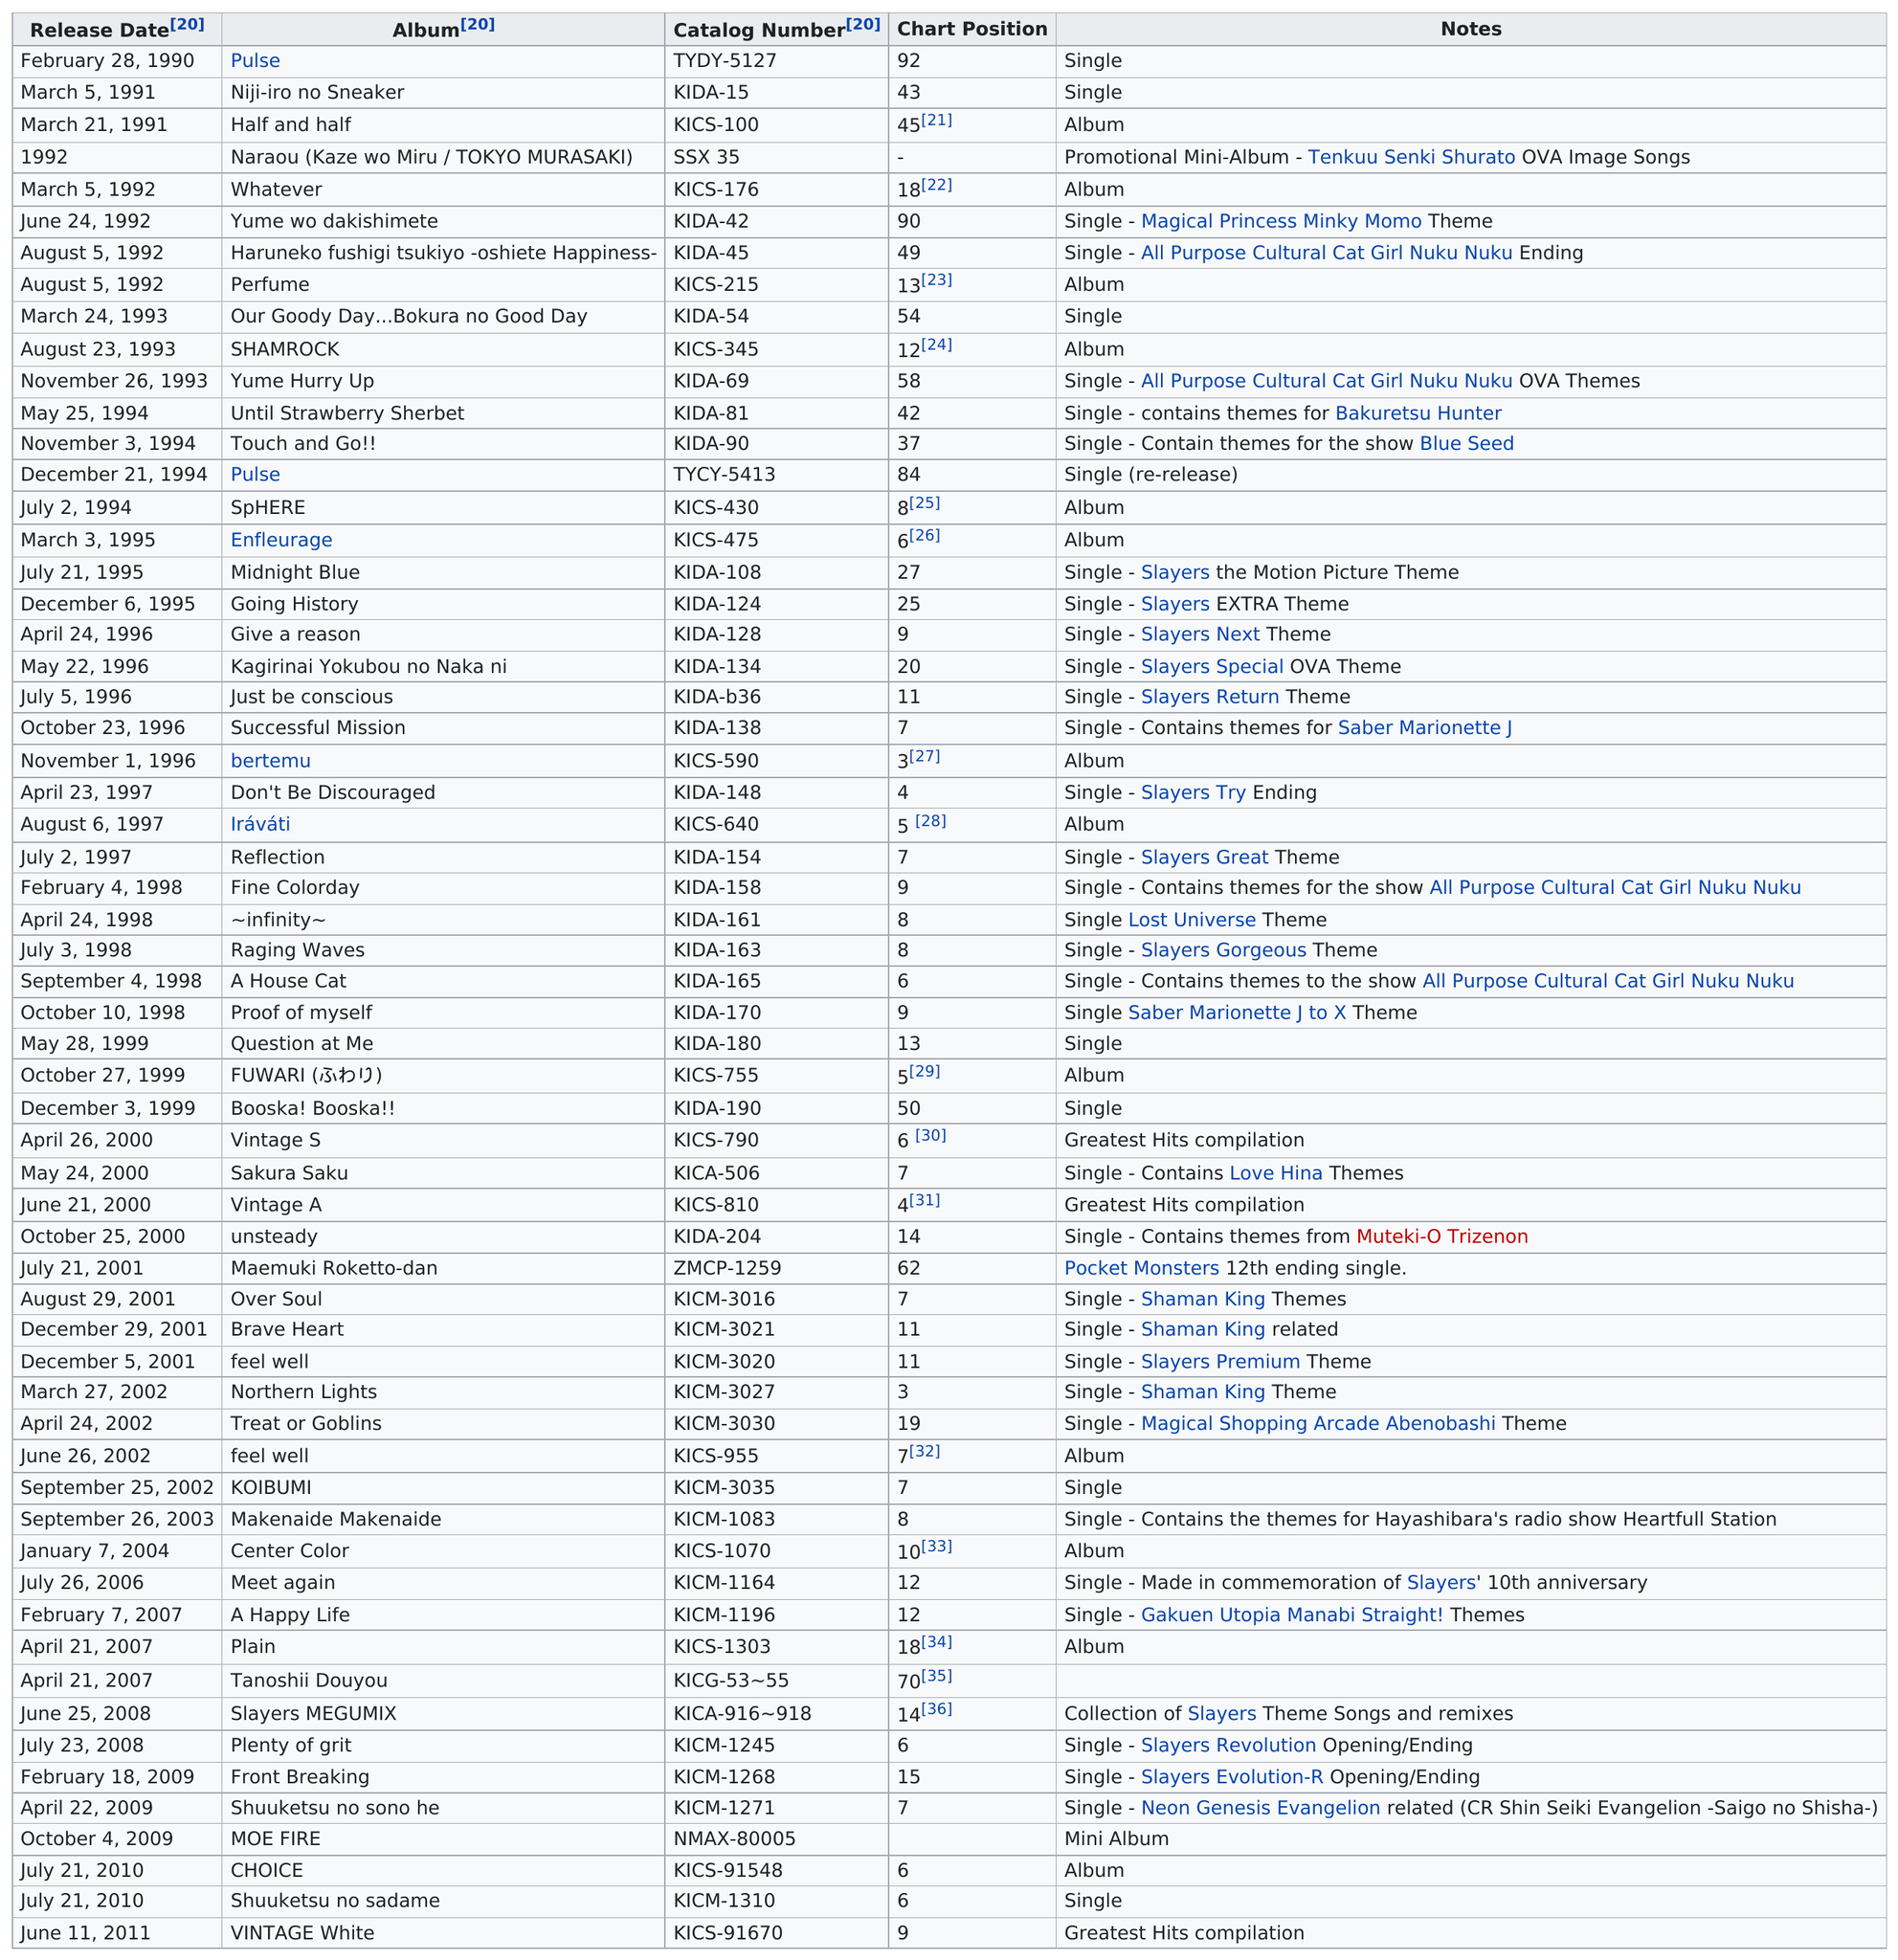Mention a couple of crucial points in this snapshot. In 2000 and later, a total of 22 albums and singles were released. Out of the 28 albums in our dataset, 28 albums held a chart position of at least 10 or less. In November, 3 albums were released. The number of pulse chart position was 92. The album that came before the current album is called Yume wo dakishimete.. 